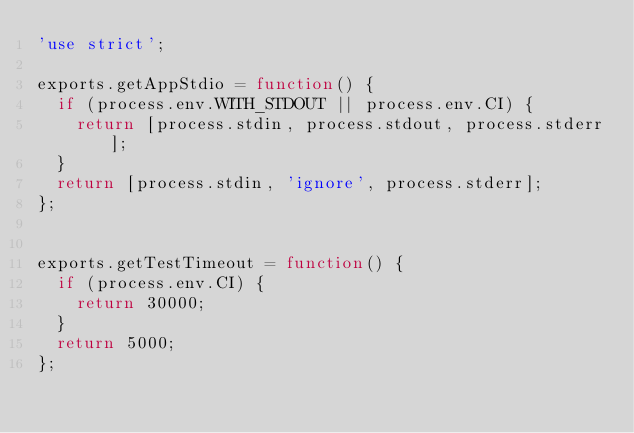<code> <loc_0><loc_0><loc_500><loc_500><_JavaScript_>'use strict';

exports.getAppStdio = function() {
  if (process.env.WITH_STDOUT || process.env.CI) {
    return [process.stdin, process.stdout, process.stderr];
  }
  return [process.stdin, 'ignore', process.stderr];
};


exports.getTestTimeout = function() {
  if (process.env.CI) {
    return 30000;
  }
  return 5000;
};
</code> 